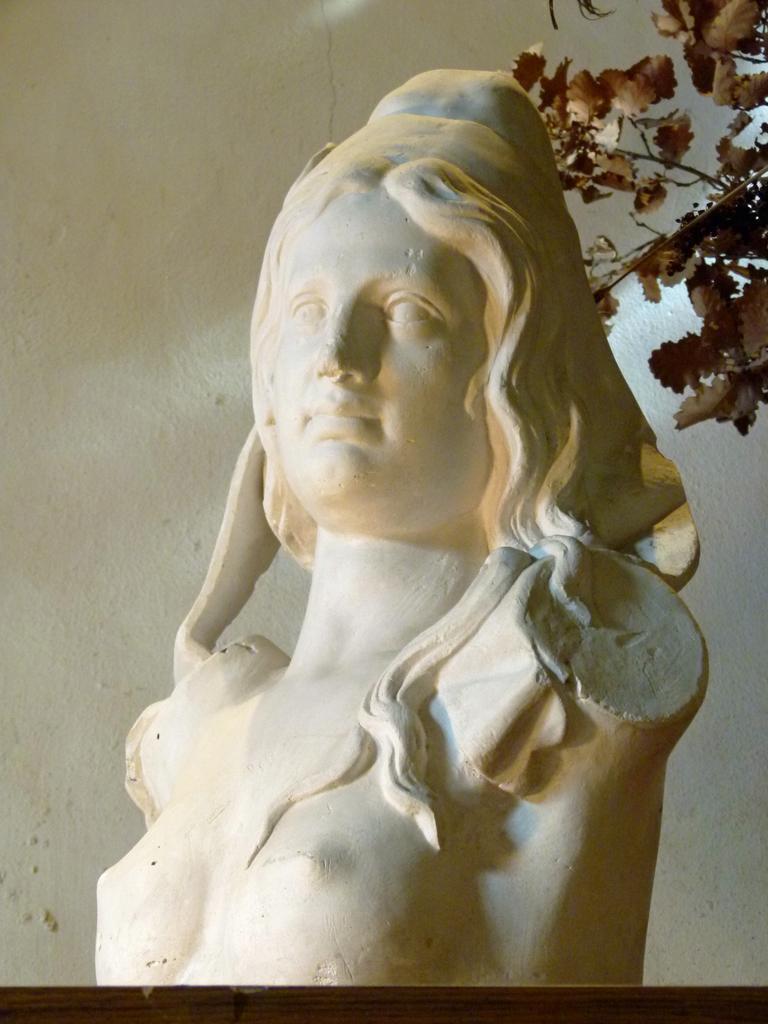Please provide a concise description of this image. In this image there is an idol on the table. Right side there are branches having leaves. Background there is a wall. 